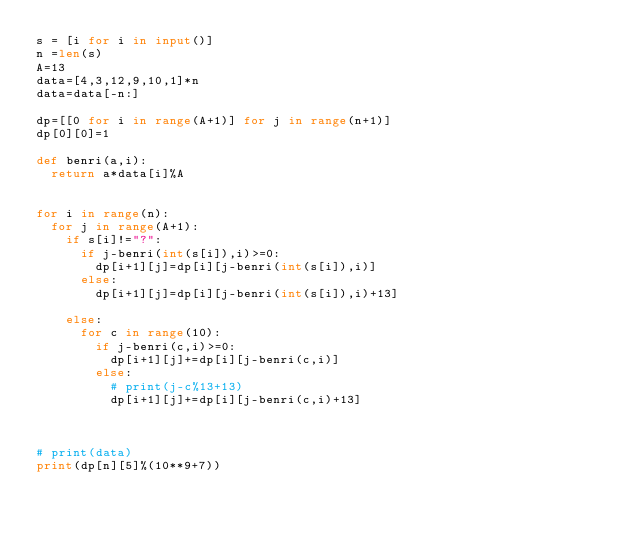Convert code to text. <code><loc_0><loc_0><loc_500><loc_500><_Python_>s = [i for i in input()]
n =len(s)
A=13
data=[4,3,12,9,10,1]*n
data=data[-n:]

dp=[[0 for i in range(A+1)] for j in range(n+1)]
dp[0][0]=1

def benri(a,i):
	return a*data[i]%A


for i in range(n):
	for j in range(A+1):
		if s[i]!="?":
			if j-benri(int(s[i]),i)>=0:
				dp[i+1][j]=dp[i][j-benri(int(s[i]),i)]
			else:
				dp[i+1][j]=dp[i][j-benri(int(s[i]),i)+13]

		else:
			for c in range(10):
				if j-benri(c,i)>=0:
					dp[i+1][j]+=dp[i][j-benri(c,i)]
				else:
					# print(j-c%13+13)
					dp[i+1][j]+=dp[i][j-benri(c,i)+13]

			
			
# print(data)
print(dp[n][5]%(10**9+7))
				
</code> 